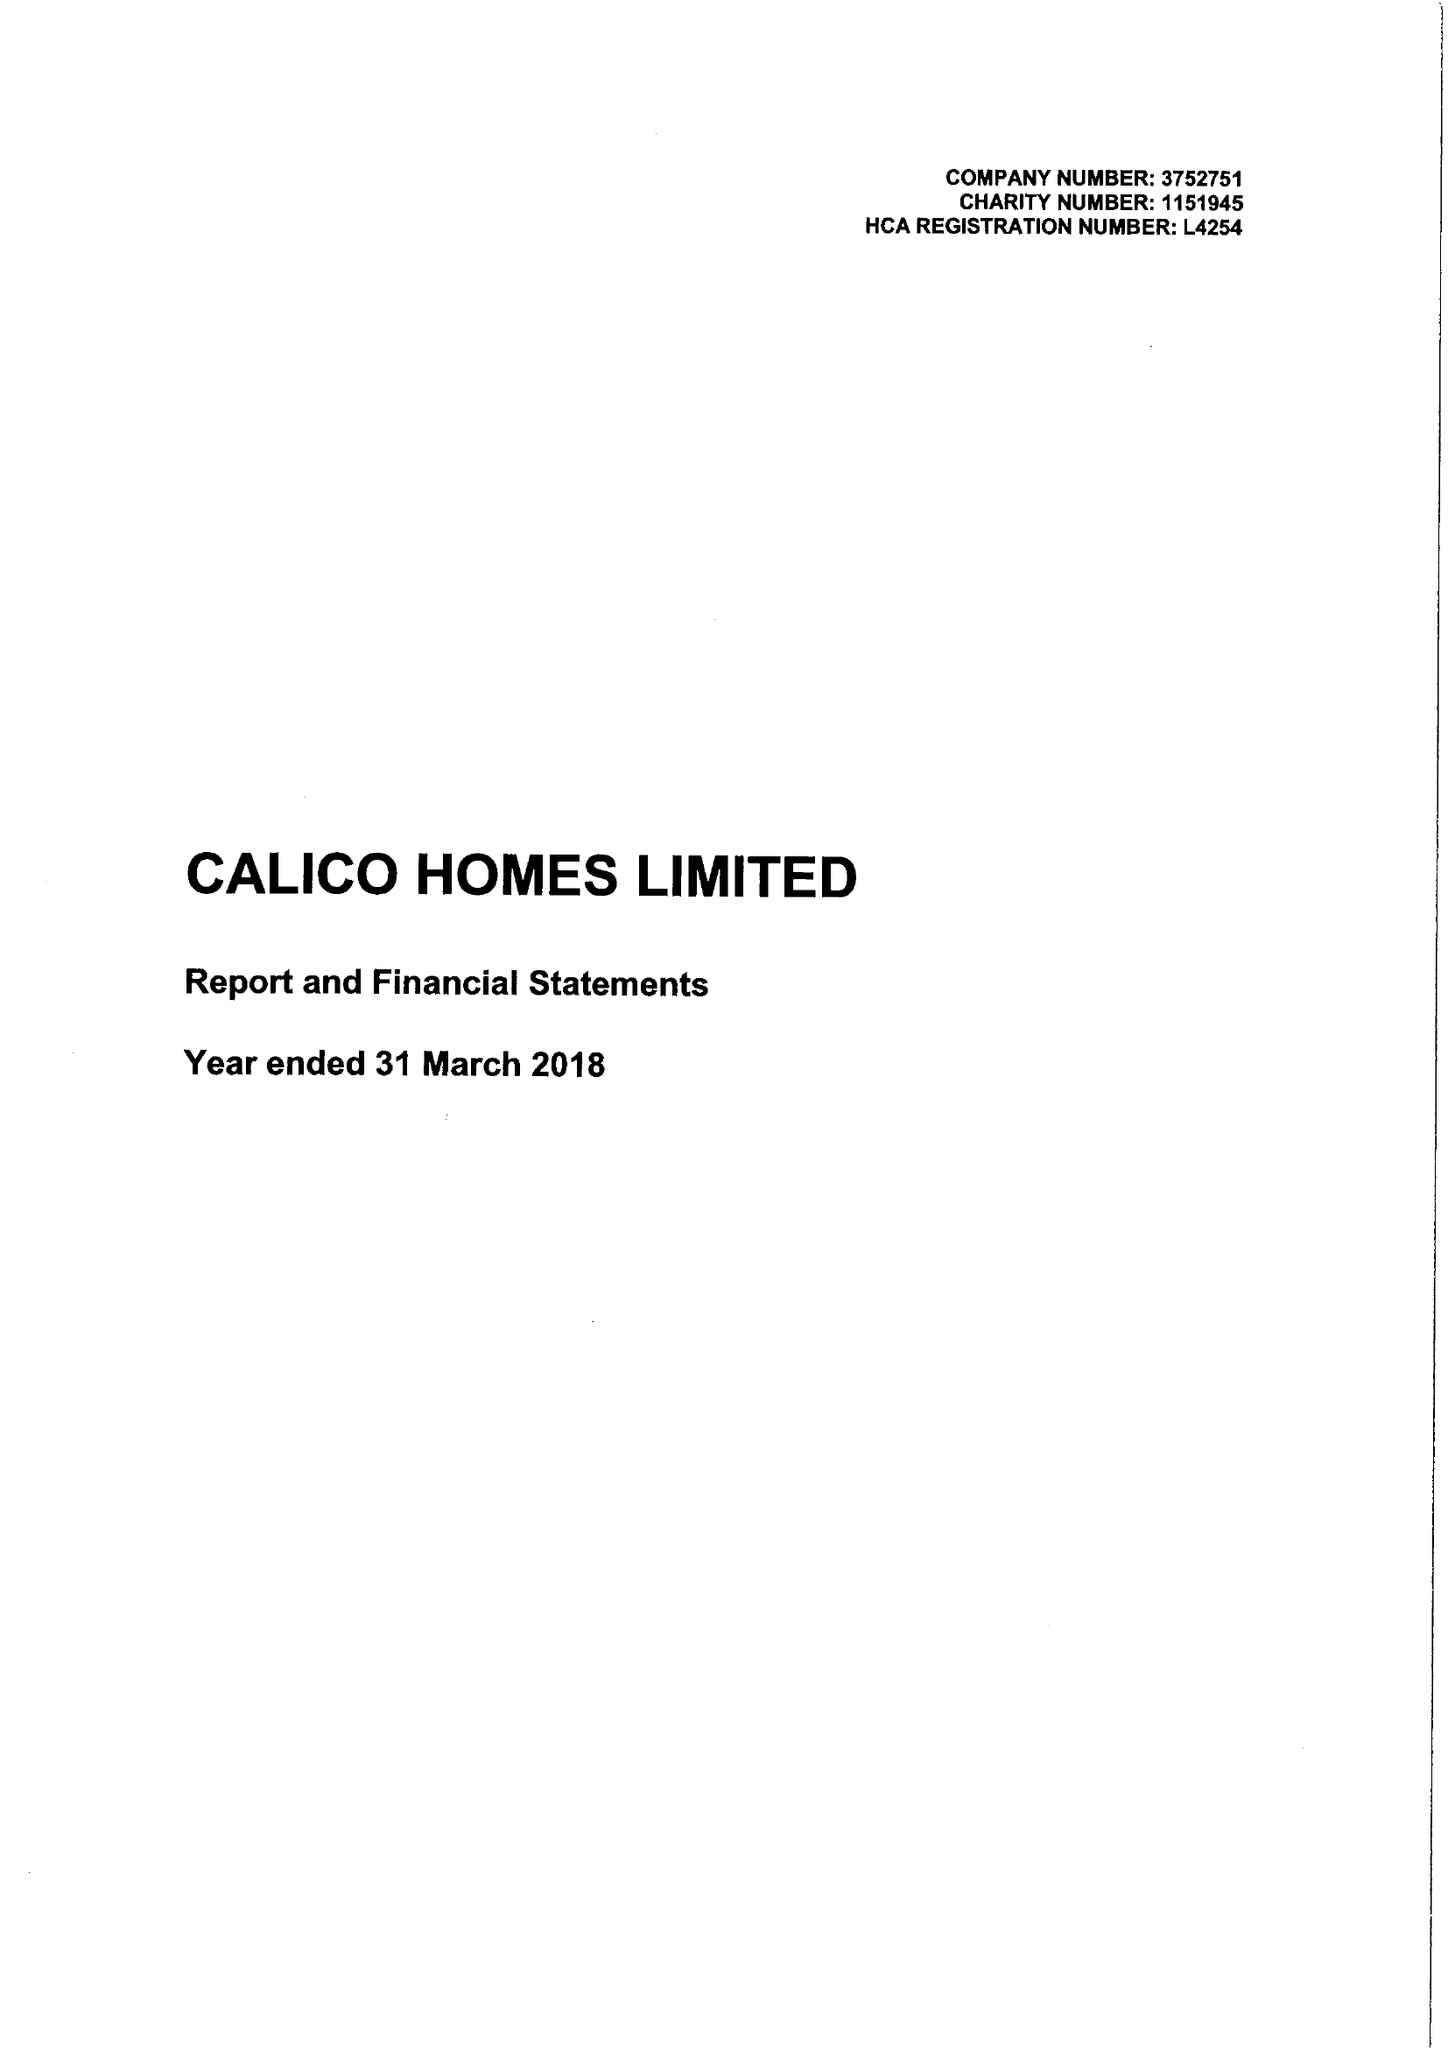What is the value for the charity_name?
Answer the question using a single word or phrase. Calico Homes Ltd. 